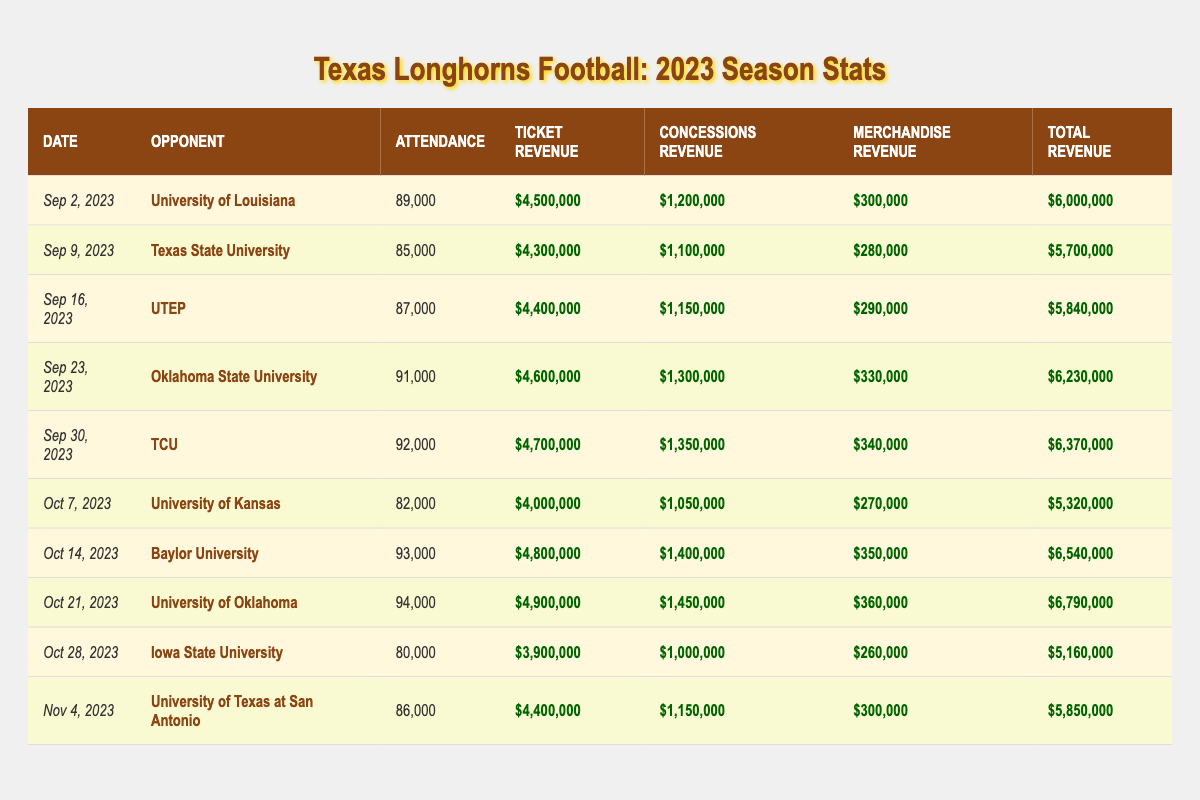What was the highest attendance recorded for a Texas football game in 2023? The data shows attendance figures for each game. The highest attendance number is for the game on October 21, 2023, against the University of Oklahoma, which had 94,000 attendees.
Answer: 94,000 What is the total revenue generated from the match against Baylor University? The total revenue from the match on October 14, 2023, against Baylor University is listed as $6,540,000.
Answer: $6,540,000 How much ticket revenue was generated in the game against TCU? The game against TCU on September 30, 2023, generated a ticket revenue of $4,700,000, as shown in the table.
Answer: $4,700,000 What was the attendance for the game played on October 7, 2023? The attendance figure for the game against the University of Kansas on October 7, 2023, is displayed as 82,000.
Answer: 82,000 Which game had the lowest total revenue? By checking each total revenue figure in the table, the game against Iowa State University on October 28, 2023, had the lowest total revenue of $5,160,000.
Answer: $5,160,000 How does the ticket revenue for the game against the University of Kansas compare to that of the game against Texas State University? The ticket revenue for the University of Kansas game is $4,000,000, and for Texas State University, it is $4,300,000. The Kansas game generated $300,000 less than the Texas State game.
Answer: $300,000 less What is the average attendance for Texas football games in 2023? To calculate the average, total the attendance across all games (89000 + 85000 + ... + 86000 = 860,000) and divide by the number of games (10). The average attendance is 860,000 / 10 = 86,000.
Answer: 86,000 Did the Texas football team generate more revenue against Oklahoma State University or against TCU? The total revenue against Oklahoma State University was $6,230,000, while against TCU, it was $6,370,000. Therefore, Texas generated more revenue against TCU.
Answer: Yes What are the total revenues for all home games with attendance over 90,000? Summing the total revenues for the games on September 23, October 14, and October 21 gives us $6,230,000 + $6,540,000 + $6,790,000 = $19,560,000.
Answer: $19,560,000 Was there any game where concessions revenue exceeded $1,400,000? Looking through the concession revenues, the game against the University of Oklahoma on October 21, 2023, had a concessions revenue of $1,450,000, which exceeds $1,400,000.
Answer: Yes 